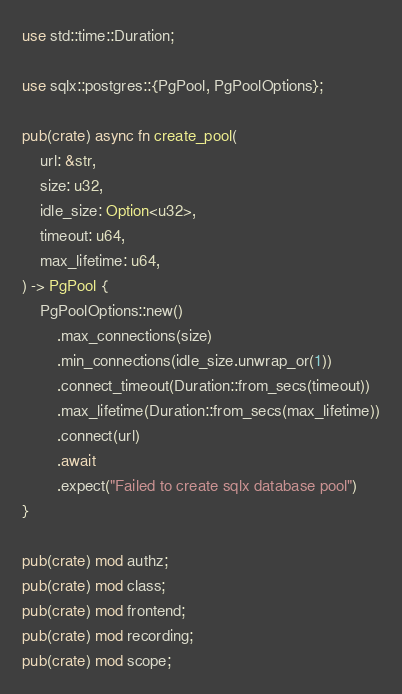Convert code to text. <code><loc_0><loc_0><loc_500><loc_500><_Rust_>use std::time::Duration;

use sqlx::postgres::{PgPool, PgPoolOptions};

pub(crate) async fn create_pool(
    url: &str,
    size: u32,
    idle_size: Option<u32>,
    timeout: u64,
    max_lifetime: u64,
) -> PgPool {
    PgPoolOptions::new()
        .max_connections(size)
        .min_connections(idle_size.unwrap_or(1))
        .connect_timeout(Duration::from_secs(timeout))
        .max_lifetime(Duration::from_secs(max_lifetime))
        .connect(url)
        .await
        .expect("Failed to create sqlx database pool")
}

pub(crate) mod authz;
pub(crate) mod class;
pub(crate) mod frontend;
pub(crate) mod recording;
pub(crate) mod scope;
</code> 